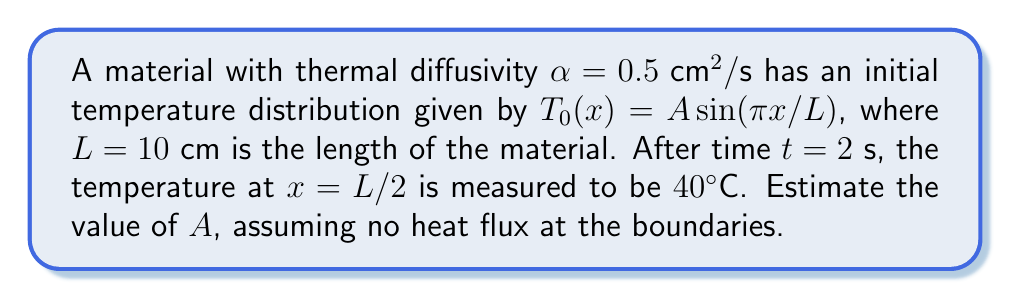Could you help me with this problem? To solve this inverse problem, we'll follow these steps:

1) The general solution for the heat equation with no heat flux at boundaries is:

   $$T(x,t) = \sum_{n=1}^{\infty} A_n e^{-\alpha n^2 \pi^2 t/L^2} \sin(n\pi x/L)$$

2) Given the initial condition $T_0(x) = A \sin(\pi x/L)$, we only have the first term of the series:

   $$T(x,t) = A e^{-\alpha \pi^2 t/L^2} \sin(\pi x/L)$$

3) We're told that at $t = 2 \text{ s}$ and $x = L/2 = 5 \text{ cm}$, $T = 40^\circ\text{C}$. Let's substitute these values:

   $$40 = A e^{-0.5 \pi^2 (2)/(10^2)} \sin(\pi (5)/10)$$

4) Simplify:
   $$40 = A e^{-\pi^2/100} \sin(\pi/2) = A e^{-\pi^2/100}$$

5) Solve for $A$:
   $$A = 40 e^{\pi^2/100} \approx 44.25$$

Therefore, we estimate the initial amplitude $A$ to be approximately 44.25°C.
Answer: $A \approx 44.25^\circ\text{C}$ 